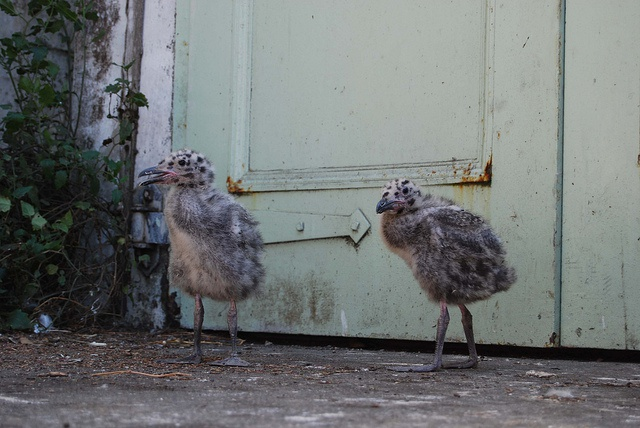Describe the objects in this image and their specific colors. I can see bird in darkgreen, gray, and black tones and bird in darkgreen, gray, and black tones in this image. 